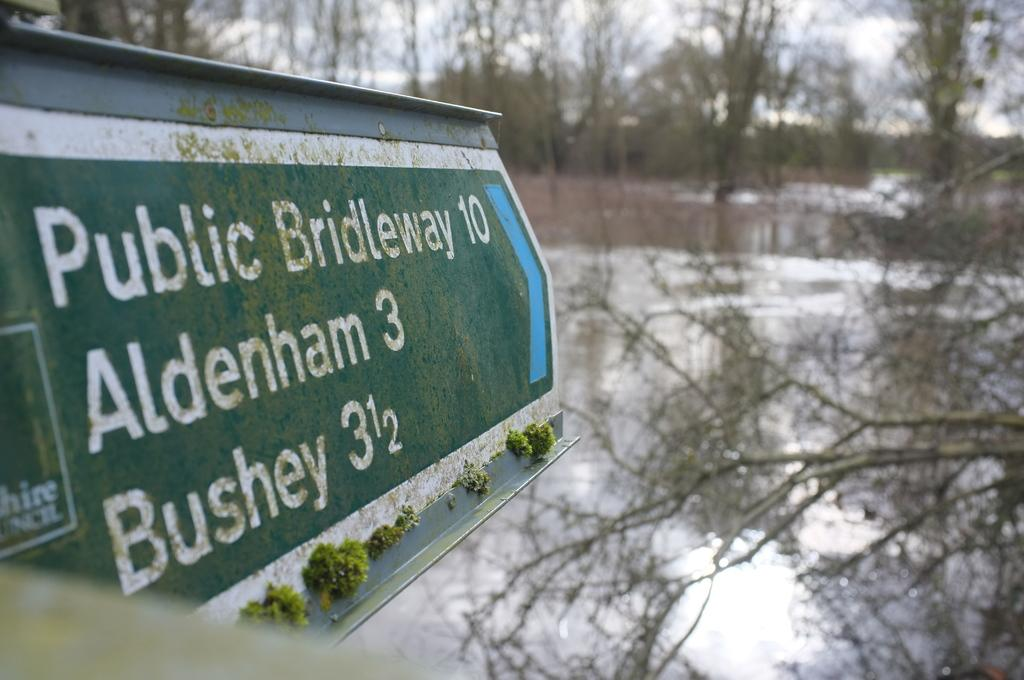What type of natural elements can be seen in the image? There are branches in the image. What object is located on the left side of the image? There is a board on the left side of the image. Can you describe the background of the image? The background of the image is blurred. How many jellyfish can be seen swimming in the background of the image? There are no jellyfish present in the image; it features branches and a board. What type of mineral is visible on the right side of the image? There is no mineral, such as quartz, present in the image. 